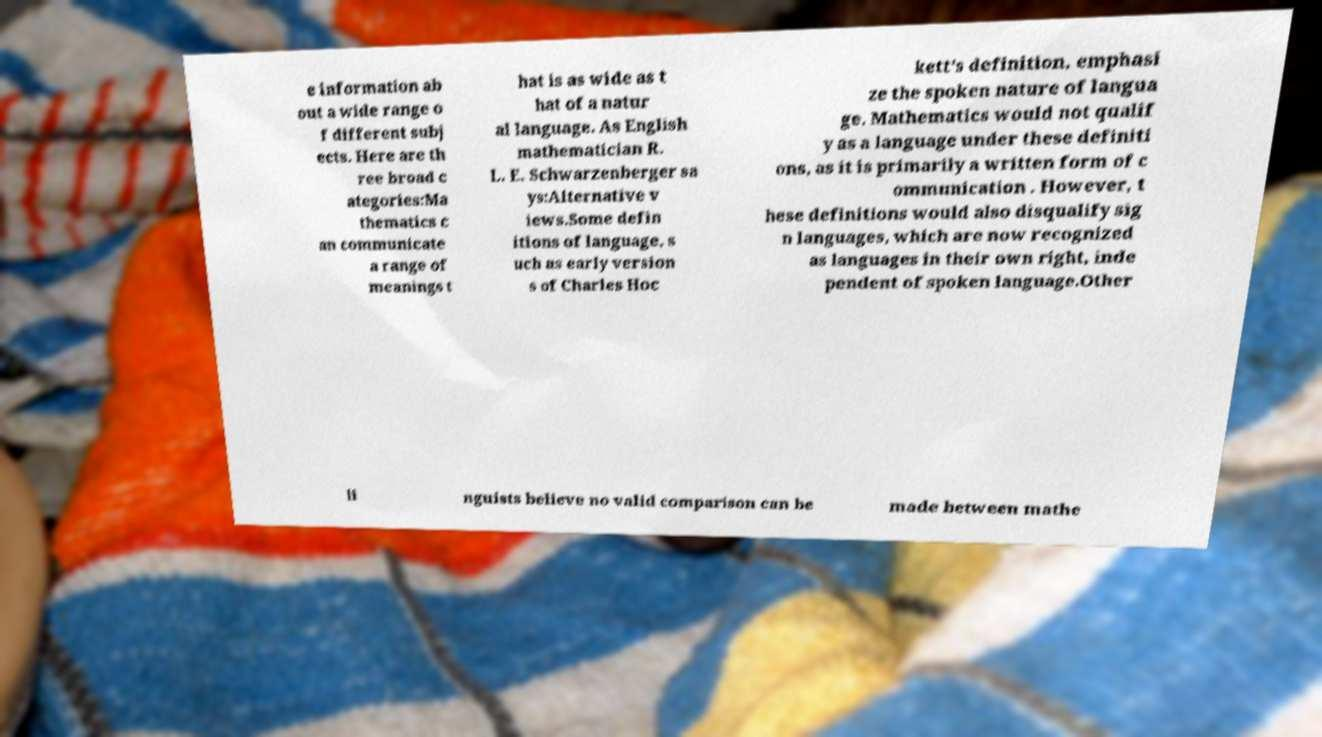Can you read and provide the text displayed in the image?This photo seems to have some interesting text. Can you extract and type it out for me? e information ab out a wide range o f different subj ects. Here are th ree broad c ategories:Ma thematics c an communicate a range of meanings t hat is as wide as t hat of a natur al language. As English mathematician R. L. E. Schwarzenberger sa ys:Alternative v iews.Some defin itions of language, s uch as early version s of Charles Hoc kett's definition, emphasi ze the spoken nature of langua ge. Mathematics would not qualif y as a language under these definiti ons, as it is primarily a written form of c ommunication . However, t hese definitions would also disqualify sig n languages, which are now recognized as languages in their own right, inde pendent of spoken language.Other li nguists believe no valid comparison can be made between mathe 